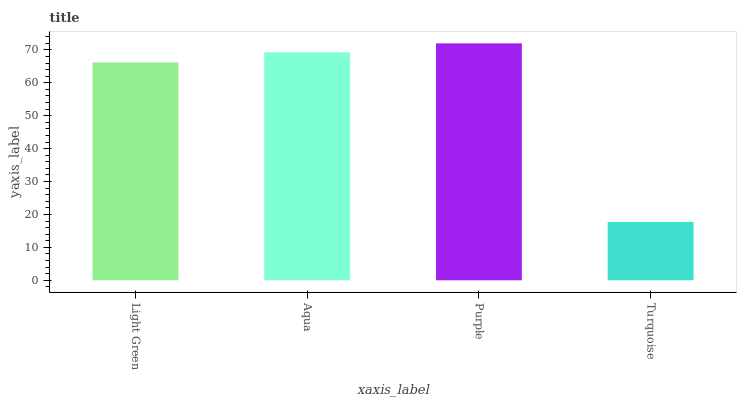Is Turquoise the minimum?
Answer yes or no. Yes. Is Purple the maximum?
Answer yes or no. Yes. Is Aqua the minimum?
Answer yes or no. No. Is Aqua the maximum?
Answer yes or no. No. Is Aqua greater than Light Green?
Answer yes or no. Yes. Is Light Green less than Aqua?
Answer yes or no. Yes. Is Light Green greater than Aqua?
Answer yes or no. No. Is Aqua less than Light Green?
Answer yes or no. No. Is Aqua the high median?
Answer yes or no. Yes. Is Light Green the low median?
Answer yes or no. Yes. Is Light Green the high median?
Answer yes or no. No. Is Purple the low median?
Answer yes or no. No. 